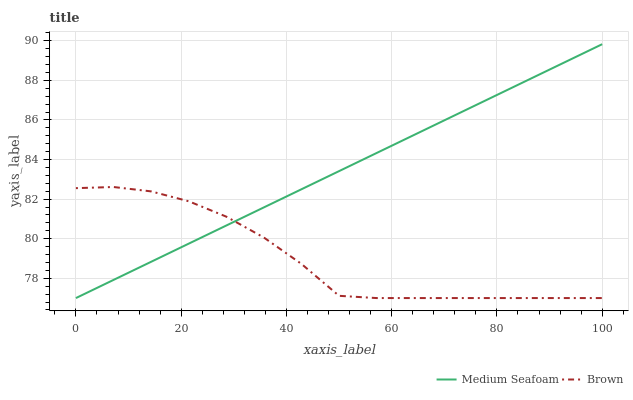Does Brown have the minimum area under the curve?
Answer yes or no. Yes. Does Medium Seafoam have the maximum area under the curve?
Answer yes or no. Yes. Does Medium Seafoam have the minimum area under the curve?
Answer yes or no. No. Is Medium Seafoam the smoothest?
Answer yes or no. Yes. Is Brown the roughest?
Answer yes or no. Yes. Is Medium Seafoam the roughest?
Answer yes or no. No. Does Brown have the lowest value?
Answer yes or no. Yes. Does Medium Seafoam have the highest value?
Answer yes or no. Yes. Does Brown intersect Medium Seafoam?
Answer yes or no. Yes. Is Brown less than Medium Seafoam?
Answer yes or no. No. Is Brown greater than Medium Seafoam?
Answer yes or no. No. 